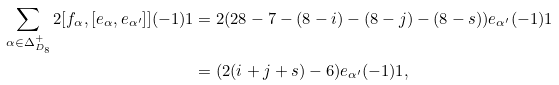Convert formula to latex. <formula><loc_0><loc_0><loc_500><loc_500>\sum _ { \alpha \in \Delta _ { D _ { 8 } } ^ { + } } 2 [ f _ { \alpha } , [ e _ { \alpha } , e _ { \alpha ^ { \prime } } ] ] ( - 1 ) 1 & = 2 ( 2 8 - 7 - ( 8 - i ) - ( 8 - j ) - ( 8 - s ) ) e _ { \alpha ^ { \prime } } ( - 1 ) 1 \\ & = ( 2 ( i + j + s ) - 6 ) e _ { \alpha ^ { \prime } } ( - 1 ) 1 ,</formula> 